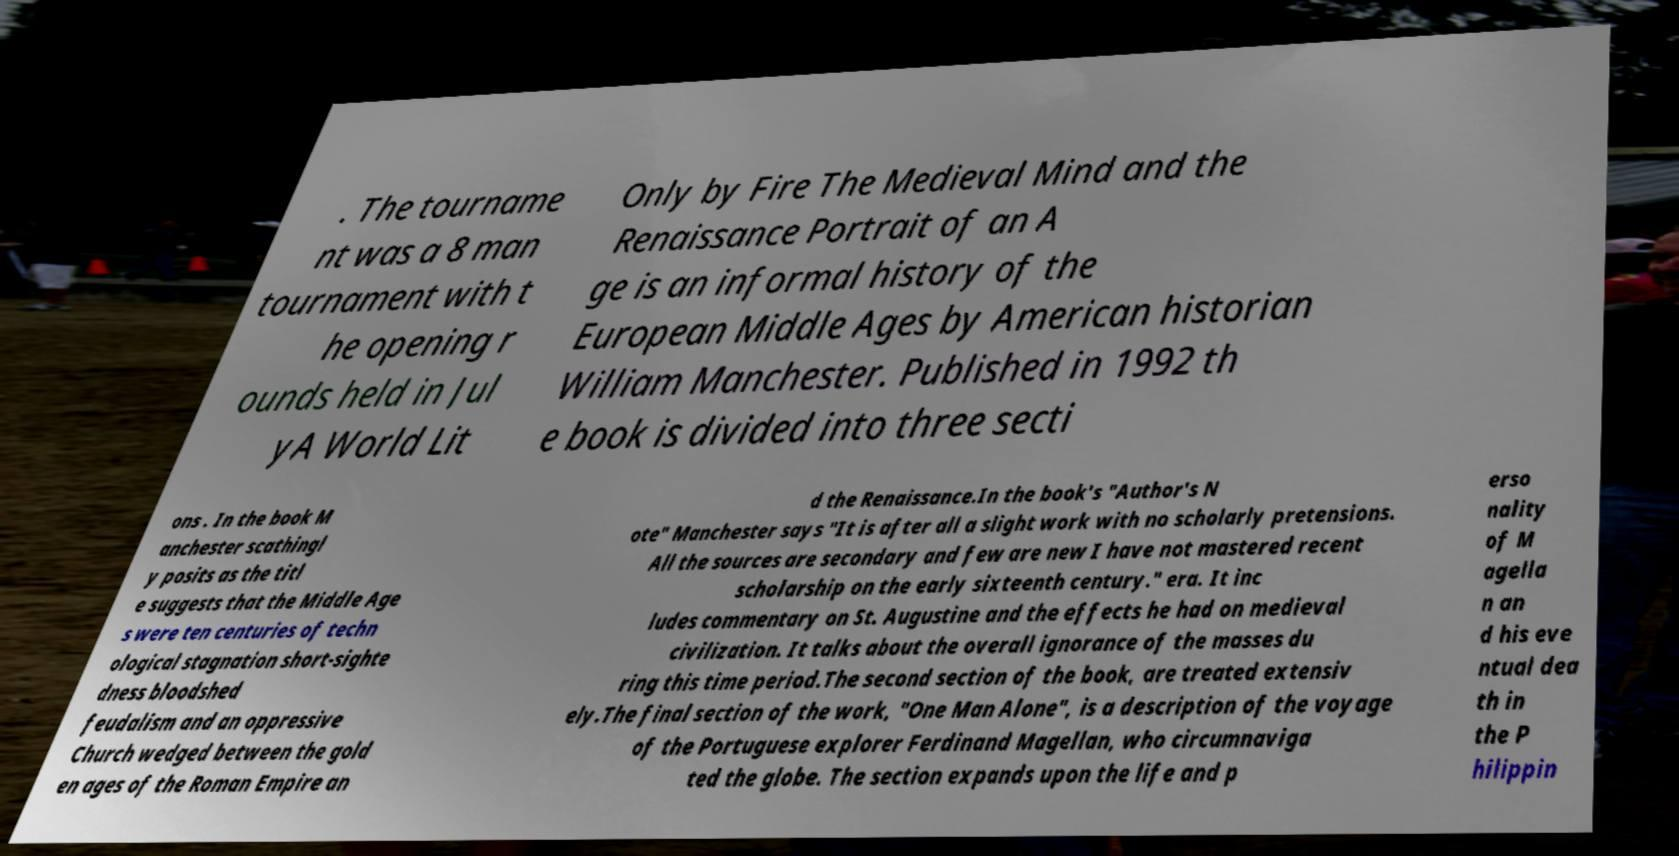There's text embedded in this image that I need extracted. Can you transcribe it verbatim? . The tourname nt was a 8 man tournament with t he opening r ounds held in Jul yA World Lit Only by Fire The Medieval Mind and the Renaissance Portrait of an A ge is an informal history of the European Middle Ages by American historian William Manchester. Published in 1992 th e book is divided into three secti ons . In the book M anchester scathingl y posits as the titl e suggests that the Middle Age s were ten centuries of techn ological stagnation short-sighte dness bloodshed feudalism and an oppressive Church wedged between the gold en ages of the Roman Empire an d the Renaissance.In the book's "Author's N ote" Manchester says "It is after all a slight work with no scholarly pretensions. All the sources are secondary and few are new I have not mastered recent scholarship on the early sixteenth century." era. It inc ludes commentary on St. Augustine and the effects he had on medieval civilization. It talks about the overall ignorance of the masses du ring this time period.The second section of the book, are treated extensiv ely.The final section of the work, "One Man Alone", is a description of the voyage of the Portuguese explorer Ferdinand Magellan, who circumnaviga ted the globe. The section expands upon the life and p erso nality of M agella n an d his eve ntual dea th in the P hilippin 